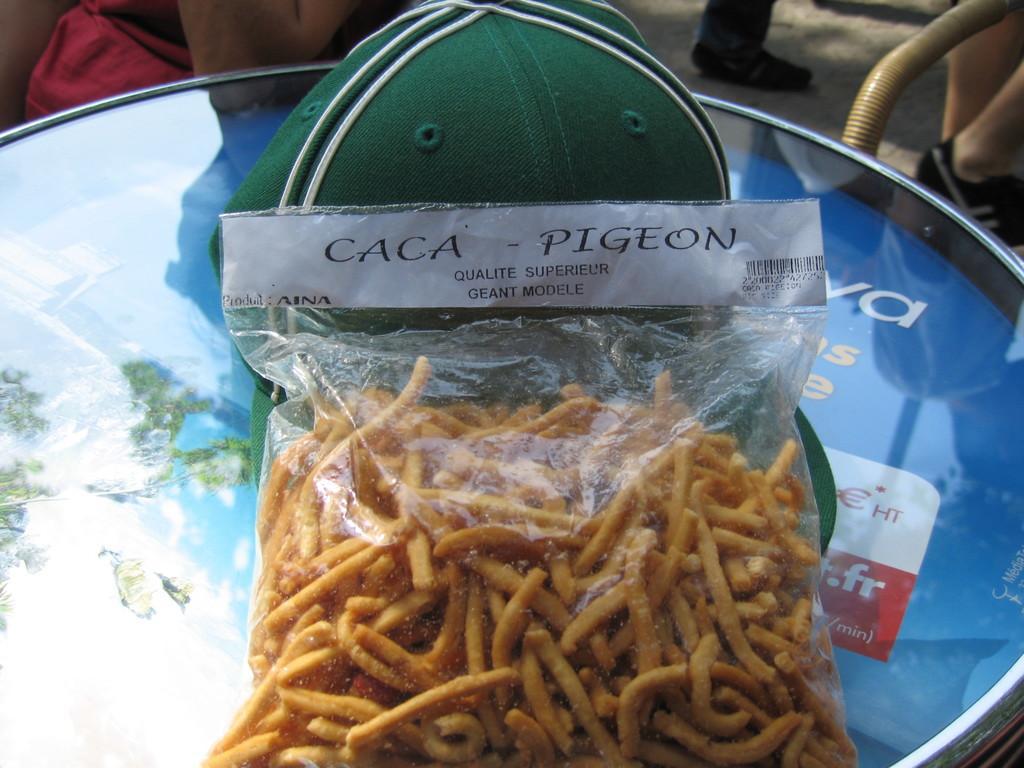Could you give a brief overview of what you see in this image? In this image I can see there are food items that are packed in a cover and there is a cap in green color. 